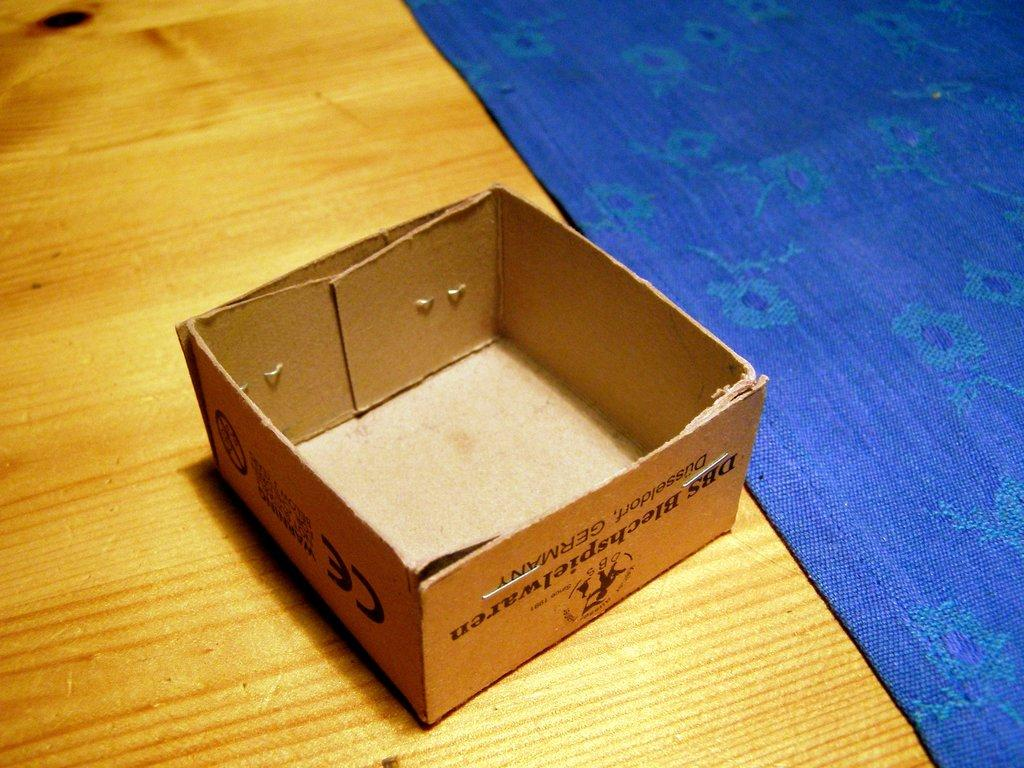<image>
Relay a brief, clear account of the picture shown. an open top box that says 'dbs blechspielwaren' on it 